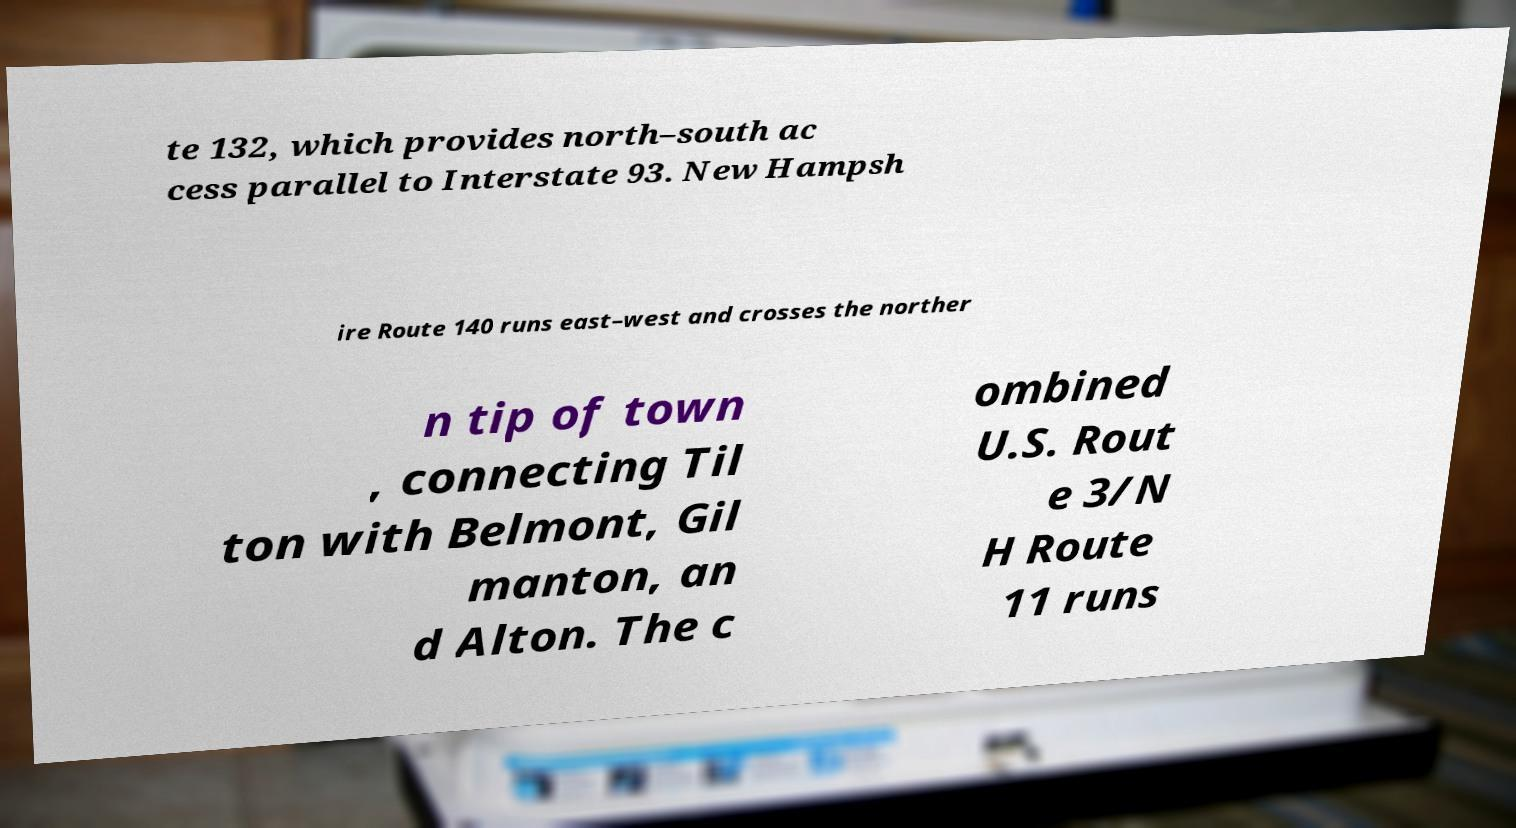Could you assist in decoding the text presented in this image and type it out clearly? te 132, which provides north–south ac cess parallel to Interstate 93. New Hampsh ire Route 140 runs east–west and crosses the norther n tip of town , connecting Til ton with Belmont, Gil manton, an d Alton. The c ombined U.S. Rout e 3/N H Route 11 runs 